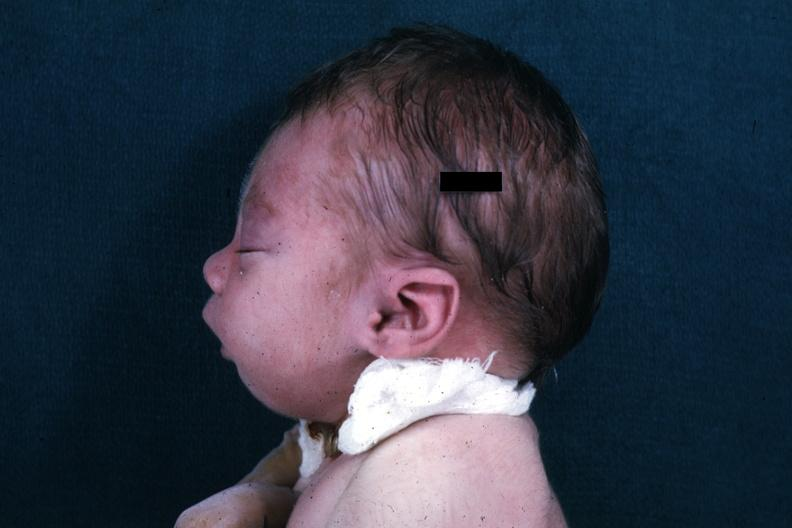what head showing mandibular lesion?
Answer the question using a single word or phrase. Lateral view of infants 